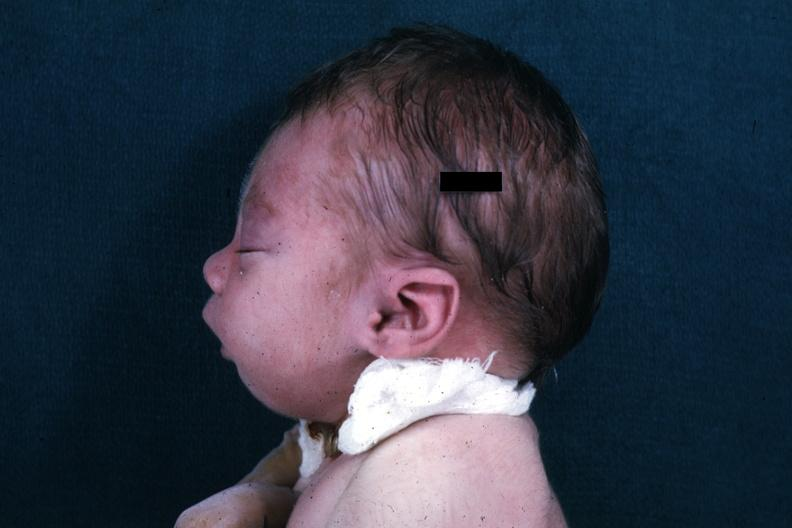what head showing mandibular lesion?
Answer the question using a single word or phrase. Lateral view of infants 